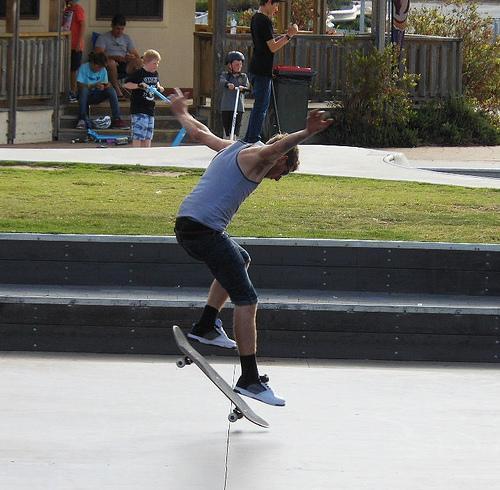How many steps are there?
Give a very brief answer. 5. How many of the people are wearing short sleeved shirts?
Give a very brief answer. 5. 